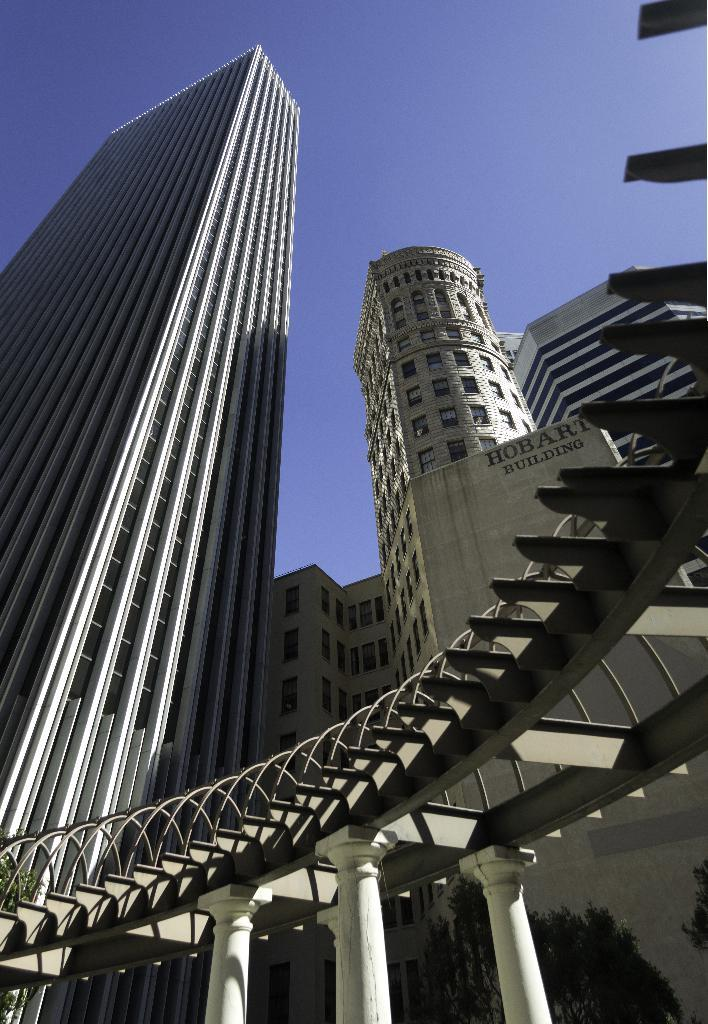What architectural features can be seen in the image? There are pillars in the image. What type of natural elements are present in the image? There are trees in the image. What type of structures are visible in the image? There are buildings with windows in the image. What can be seen in the background of the image? The sky is visible in the background of the image. Can you see any feathers floating in the sky in the image? There are no feathers visible in the image; only pillars, trees, buildings, and the sky can be seen. How comfortable are the pillars in the image? The comfort level of the pillars cannot be determined from the image, as they are inanimate objects. 